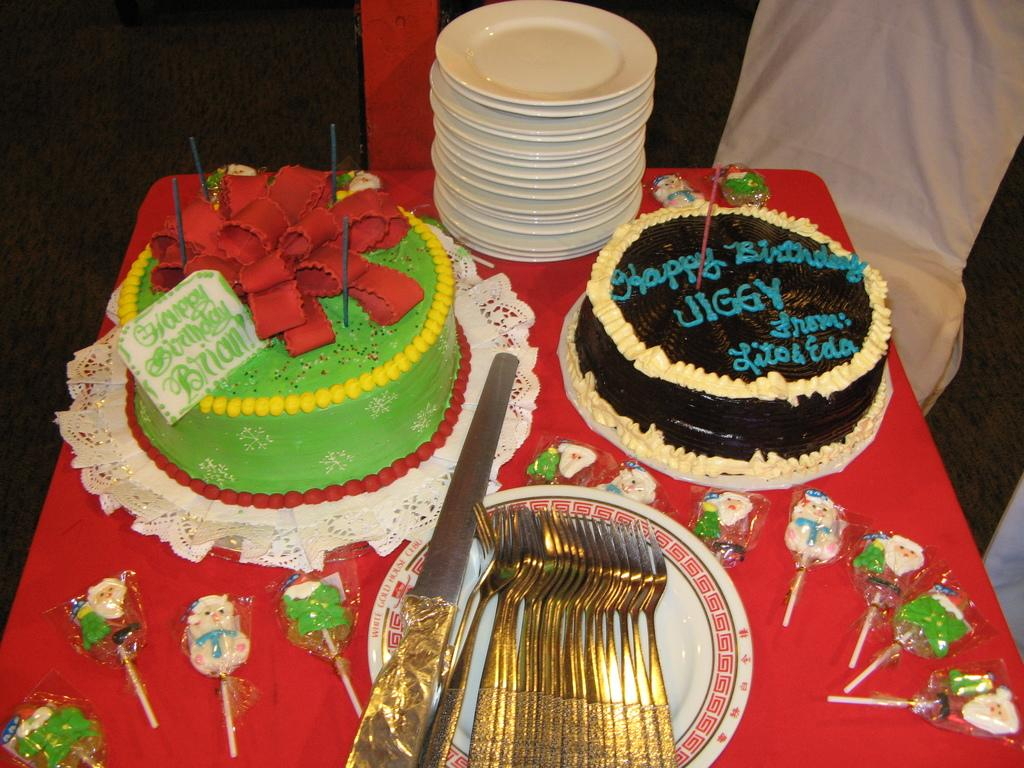What colors are the cakes in the image? There is a green color cake on the left side of the image and a black color cake on the right side of the image. Where are the forks located in the image? The forks are in a white color plate in the middle of the image. What type of substance is the fly sitting on in the image? There is no fly present in the image, so it is not possible to answer that question. 